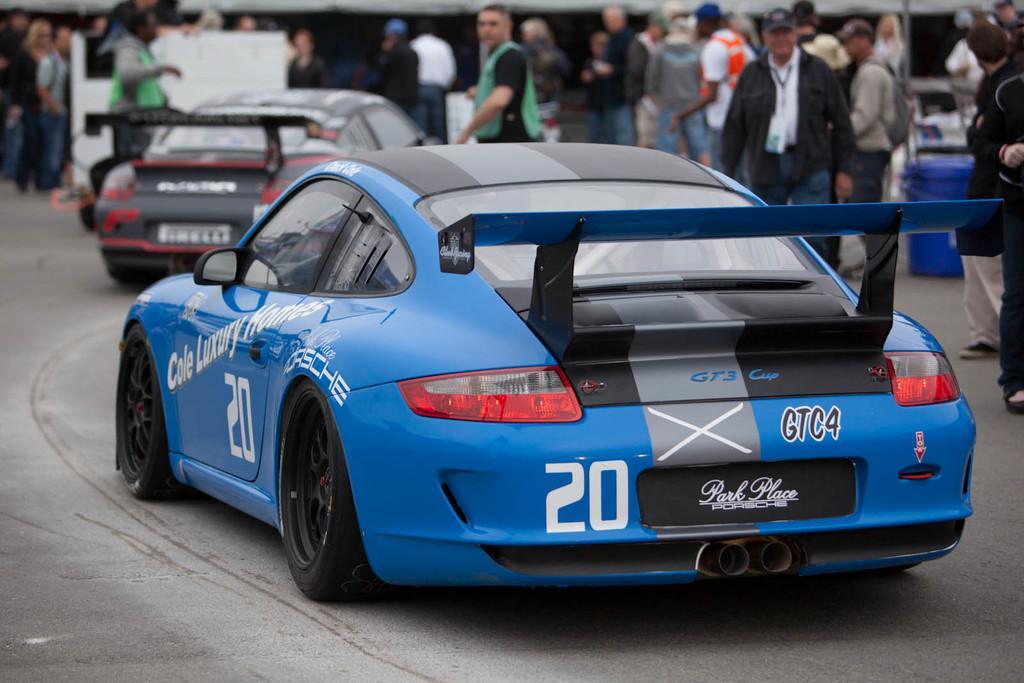In one or two sentences, can you explain what this image depicts? In the image there are two cars going on the road and in the back there are many people standing all over the road. 